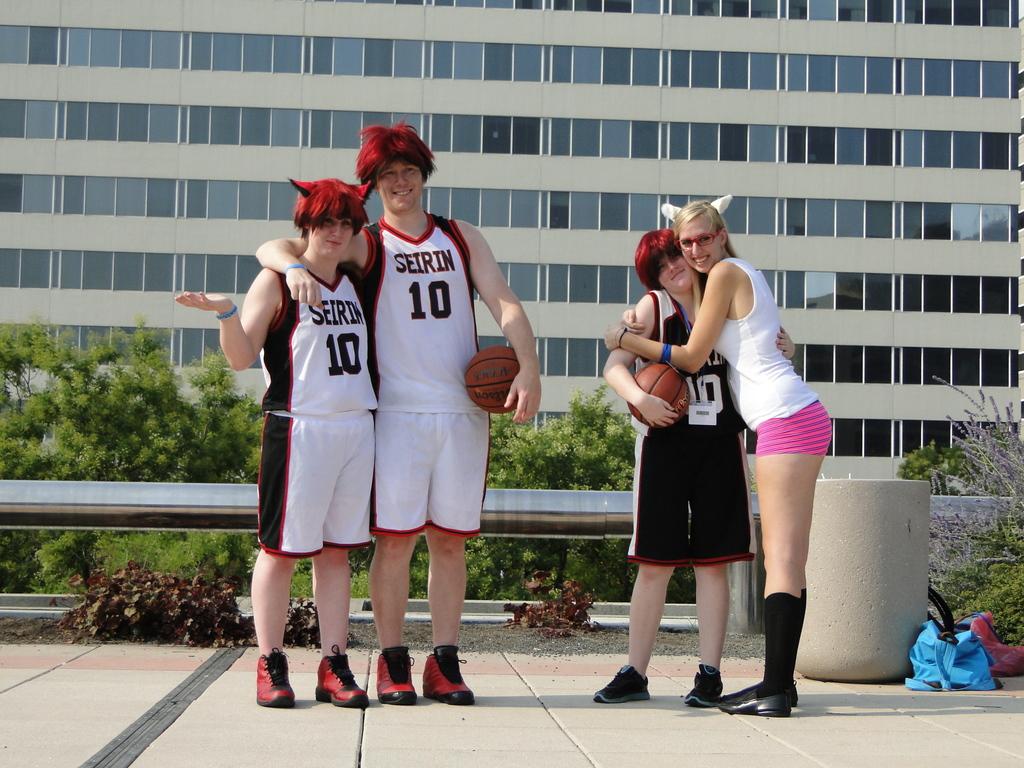Are they both wearing number 10 jerseys?
Make the answer very short. Yes. What is the name of the team?
Keep it short and to the point. Seirin. 